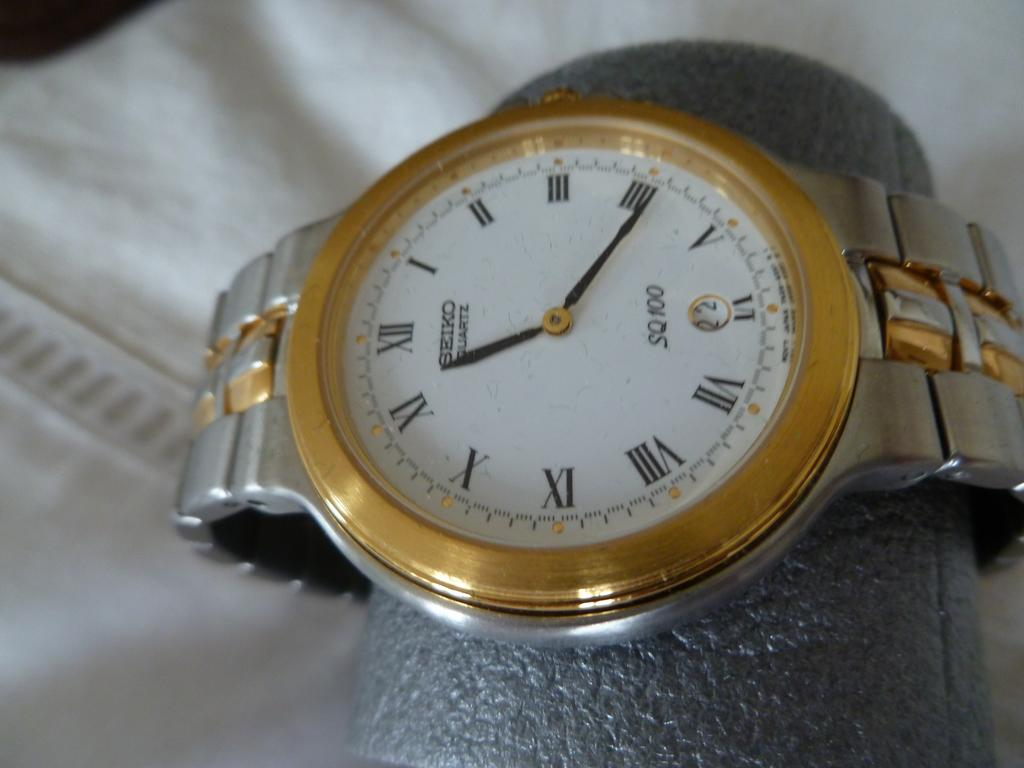<image>
Relay a brief, clear account of the picture shown. A Seiko watch shows a time of 11:21. 